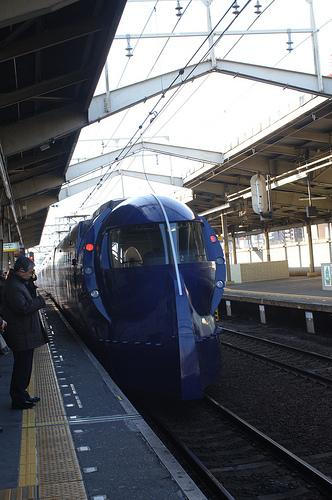Mention the most significant color in the image along with the object it corresponds to. The color blue is the most prominent, as it is the color of the passenger train that is stationary at the station. Give a concise description of the scene in the image. A stationary blue passenger train at the station, with a man on the platform looking at his phone and yellow safety lines on the ground. Describe any additional infrastructure visible in the image. There is a train stop platform with yellow markings, empty train tracks, a wire system guiding the train, and a roof area over the station. Briefly mention the human activity in the image. A man is waiting on the train platform, while looking at his cellphone. Write about the primary transportation method present and any key features of the surrounding environment. The main transportation is a blue passenger train that is stopped at the station, with features such as a platform, yellow safety line, and wire system for guidance. Give a short description of the image, including the main subject and their activity. A man is standing on the platform waiting for the blue passenger train, which is stopped at the station, as indicated by the red light on the front. Briefly describe what the man in the image is doing. A man, wearing a black jacket, is standing on the train platform while looking at his cellphone. Discuss the primary mode of transportation in the image and any visible indicator of its state. The blue train serves as the main transportation, with the red light on its front signaling that it is currently stopped. Point out the visual cue that tells us the train is not currently in motion. The red round light on the front of the train indicates that it is stopped. Mention the primary object in the image and its prominent features. A blue passenger train is stopped at the station, with its driver front window and a red light indicating that it is not moving. 